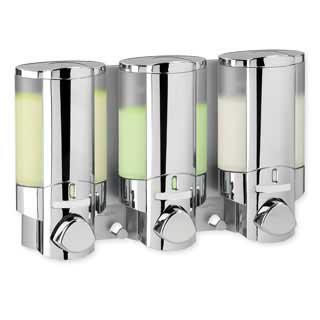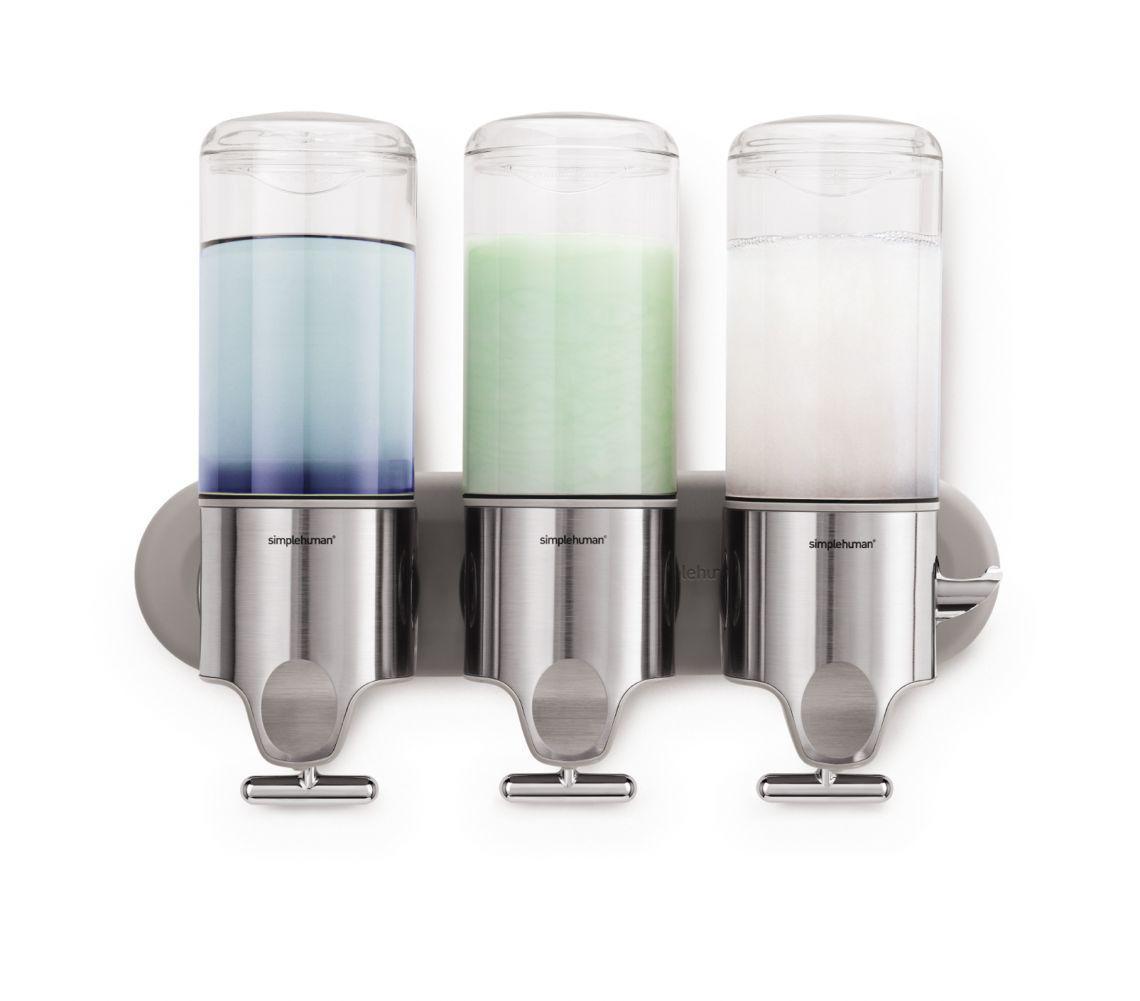The first image is the image on the left, the second image is the image on the right. For the images displayed, is the sentence "One image features an opaque dispenser style with a top nozzle, and the other features a style that dispenses from the bottom and has a clear body." factually correct? Answer yes or no. No. The first image is the image on the left, the second image is the image on the right. Evaluate the accuracy of this statement regarding the images: "At least one soap dispenser has a pump on top.". Is it true? Answer yes or no. No. 